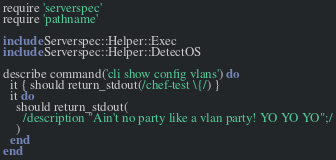Convert code to text. <code><loc_0><loc_0><loc_500><loc_500><_Ruby_>require 'serverspec'
require 'pathname'

include Serverspec::Helper::Exec
include Serverspec::Helper::DetectOS

describe command('cli show config vlans') do
  it { should return_stdout(/chef-test \{/) }
  it do
    should return_stdout(
      /description "Ain't no party like a vlan party! YO YO YO";/
    )
  end
end
</code> 